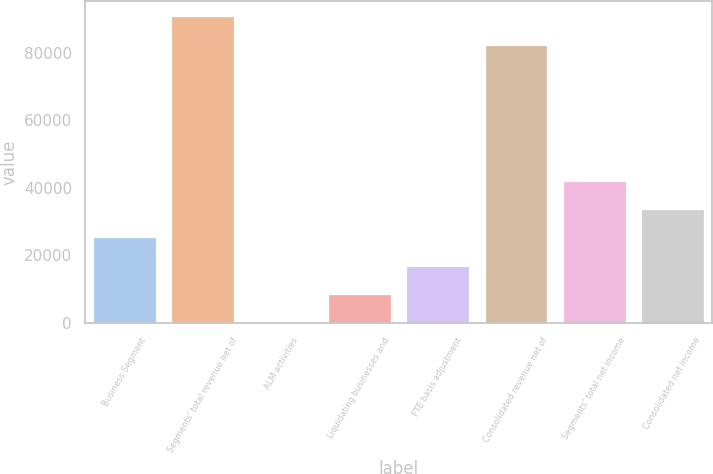<chart> <loc_0><loc_0><loc_500><loc_500><bar_chart><fcel>Business Segment<fcel>Segments' total revenue net of<fcel>ALM activities<fcel>Liquidating businesses and<fcel>FTE basis adjustment<fcel>Consolidated revenue net of<fcel>Segments' total net income<fcel>Consolidated net income<nl><fcel>25376.4<fcel>90886.8<fcel>237<fcel>8616.8<fcel>16996.6<fcel>82507<fcel>42136<fcel>33756.2<nl></chart> 